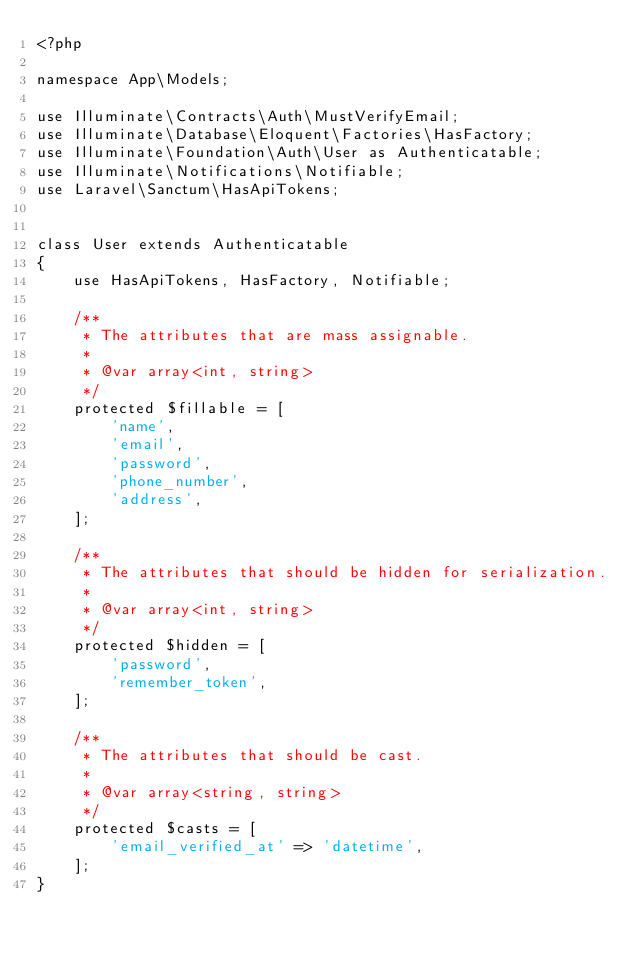<code> <loc_0><loc_0><loc_500><loc_500><_PHP_><?php

namespace App\Models;

use Illuminate\Contracts\Auth\MustVerifyEmail;
use Illuminate\Database\Eloquent\Factories\HasFactory;
use Illuminate\Foundation\Auth\User as Authenticatable;
use Illuminate\Notifications\Notifiable;
use Laravel\Sanctum\HasApiTokens;


class User extends Authenticatable
{
    use HasApiTokens, HasFactory, Notifiable;

    /**
     * The attributes that are mass assignable.
     *
     * @var array<int, string>
     */
    protected $fillable = [
        'name',
        'email',
        'password',
        'phone_number',
        'address',
    ];

    /**
     * The attributes that should be hidden for serialization.
     *
     * @var array<int, string>
     */
    protected $hidden = [
        'password',
        'remember_token',
    ];

    /**
     * The attributes that should be cast.
     *
     * @var array<string, string>
     */
    protected $casts = [
        'email_verified_at' => 'datetime',
    ];
}
</code> 